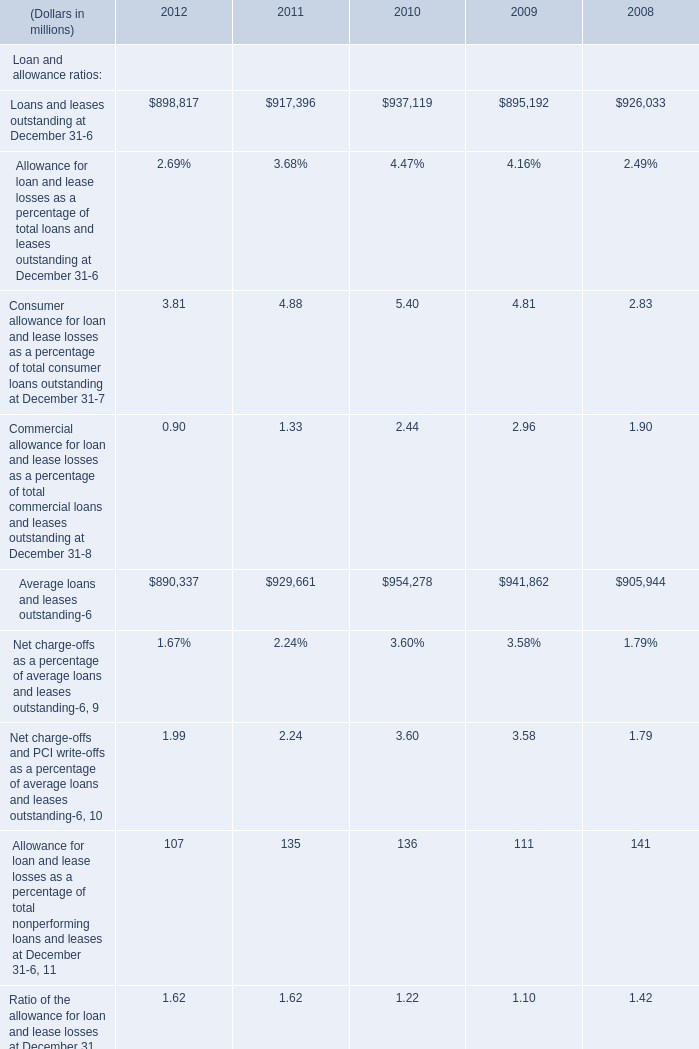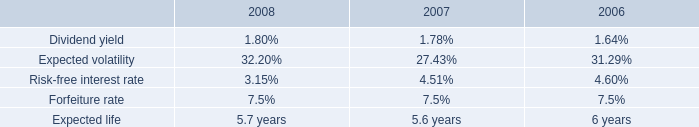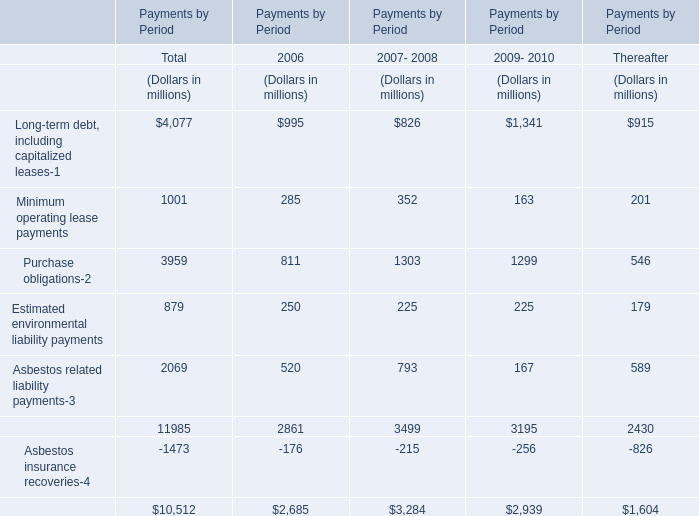what was the percentage increase in the number of common shares authorized to be issued under the 2004 ltip 
Computations: ((19000000 - 15000000) / 15000000)
Answer: 0.26667. 